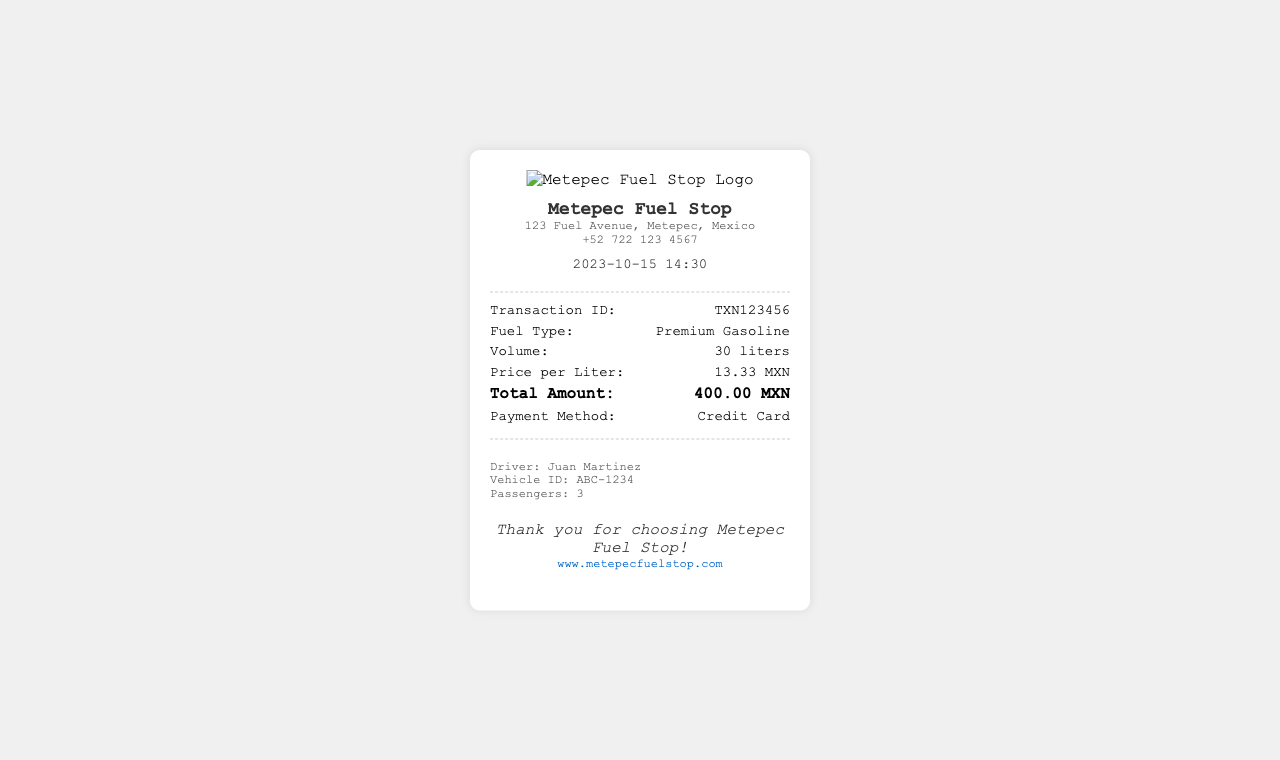What is the transaction ID? The transaction ID is a unique identifier for the purchase, listed in the details section.
Answer: TXN123456 What fuel type was purchased? The fuel type is clearly stated in the details section of the receipt.
Answer: Premium Gasoline How many liters of fuel were purchased? The volume of fuel is specified in the details section of the receipt.
Answer: 30 liters What was the price per liter? The price per liter is provided in the receipt's details section.
Answer: 13.33 MXN What was the total amount spent? The total amount is the final value mentioned in the details section of the receipt.
Answer: 400.00 MXN Who is the driver? The driver's name is provided in the customer information section.
Answer: Juan Martinez What vehicle ID is listed? The vehicle ID can be found in the customer information section of the document.
Answer: ABC-1234 What payment method was used? The payment method is clearly mentioned in the details section of the receipt.
Answer: Credit Card How many passengers were there? The number of passengers is specified in the customer information section of the receipt.
Answer: 3 